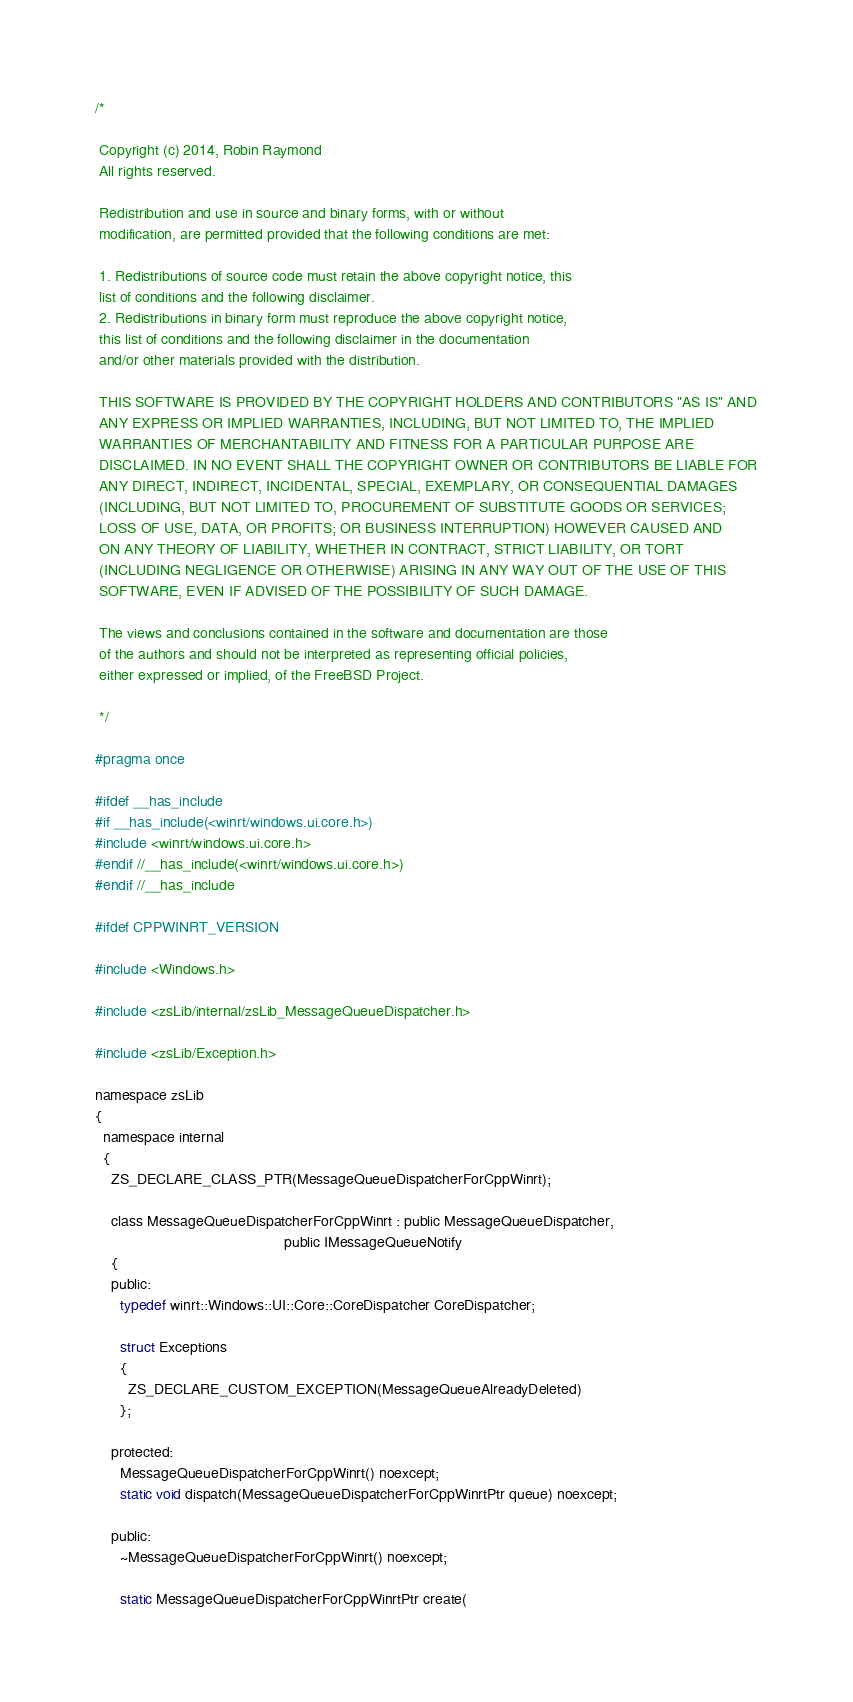Convert code to text. <code><loc_0><loc_0><loc_500><loc_500><_C_>/*

 Copyright (c) 2014, Robin Raymond
 All rights reserved.

 Redistribution and use in source and binary forms, with or without
 modification, are permitted provided that the following conditions are met:

 1. Redistributions of source code must retain the above copyright notice, this
 list of conditions and the following disclaimer.
 2. Redistributions in binary form must reproduce the above copyright notice,
 this list of conditions and the following disclaimer in the documentation
 and/or other materials provided with the distribution.

 THIS SOFTWARE IS PROVIDED BY THE COPYRIGHT HOLDERS AND CONTRIBUTORS "AS IS" AND
 ANY EXPRESS OR IMPLIED WARRANTIES, INCLUDING, BUT NOT LIMITED TO, THE IMPLIED
 WARRANTIES OF MERCHANTABILITY AND FITNESS FOR A PARTICULAR PURPOSE ARE
 DISCLAIMED. IN NO EVENT SHALL THE COPYRIGHT OWNER OR CONTRIBUTORS BE LIABLE FOR
 ANY DIRECT, INDIRECT, INCIDENTAL, SPECIAL, EXEMPLARY, OR CONSEQUENTIAL DAMAGES
 (INCLUDING, BUT NOT LIMITED TO, PROCUREMENT OF SUBSTITUTE GOODS OR SERVICES;
 LOSS OF USE, DATA, OR PROFITS; OR BUSINESS INTERRUPTION) HOWEVER CAUSED AND
 ON ANY THEORY OF LIABILITY, WHETHER IN CONTRACT, STRICT LIABILITY, OR TORT
 (INCLUDING NEGLIGENCE OR OTHERWISE) ARISING IN ANY WAY OUT OF THE USE OF THIS
 SOFTWARE, EVEN IF ADVISED OF THE POSSIBILITY OF SUCH DAMAGE.

 The views and conclusions contained in the software and documentation are those
 of the authors and should not be interpreted as representing official policies,
 either expressed or implied, of the FreeBSD Project.
 
 */

#pragma once

#ifdef __has_include
#if __has_include(<winrt/windows.ui.core.h>)
#include <winrt/windows.ui.core.h>
#endif //__has_include(<winrt/windows.ui.core.h>)
#endif //__has_include

#ifdef CPPWINRT_VERSION

#include <Windows.h>

#include <zsLib/internal/zsLib_MessageQueueDispatcher.h>

#include <zsLib/Exception.h>

namespace zsLib
{
  namespace internal
  {
    ZS_DECLARE_CLASS_PTR(MessageQueueDispatcherForCppWinrt);

    class MessageQueueDispatcherForCppWinrt : public MessageQueueDispatcher,
                                              public IMessageQueueNotify
    {
    public:
      typedef winrt::Windows::UI::Core::CoreDispatcher CoreDispatcher;

      struct Exceptions
      {
        ZS_DECLARE_CUSTOM_EXCEPTION(MessageQueueAlreadyDeleted)
      };

    protected:
      MessageQueueDispatcherForCppWinrt() noexcept;
      static void dispatch(MessageQueueDispatcherForCppWinrtPtr queue) noexcept;

    public:
      ~MessageQueueDispatcherForCppWinrt() noexcept;

      static MessageQueueDispatcherForCppWinrtPtr create(</code> 